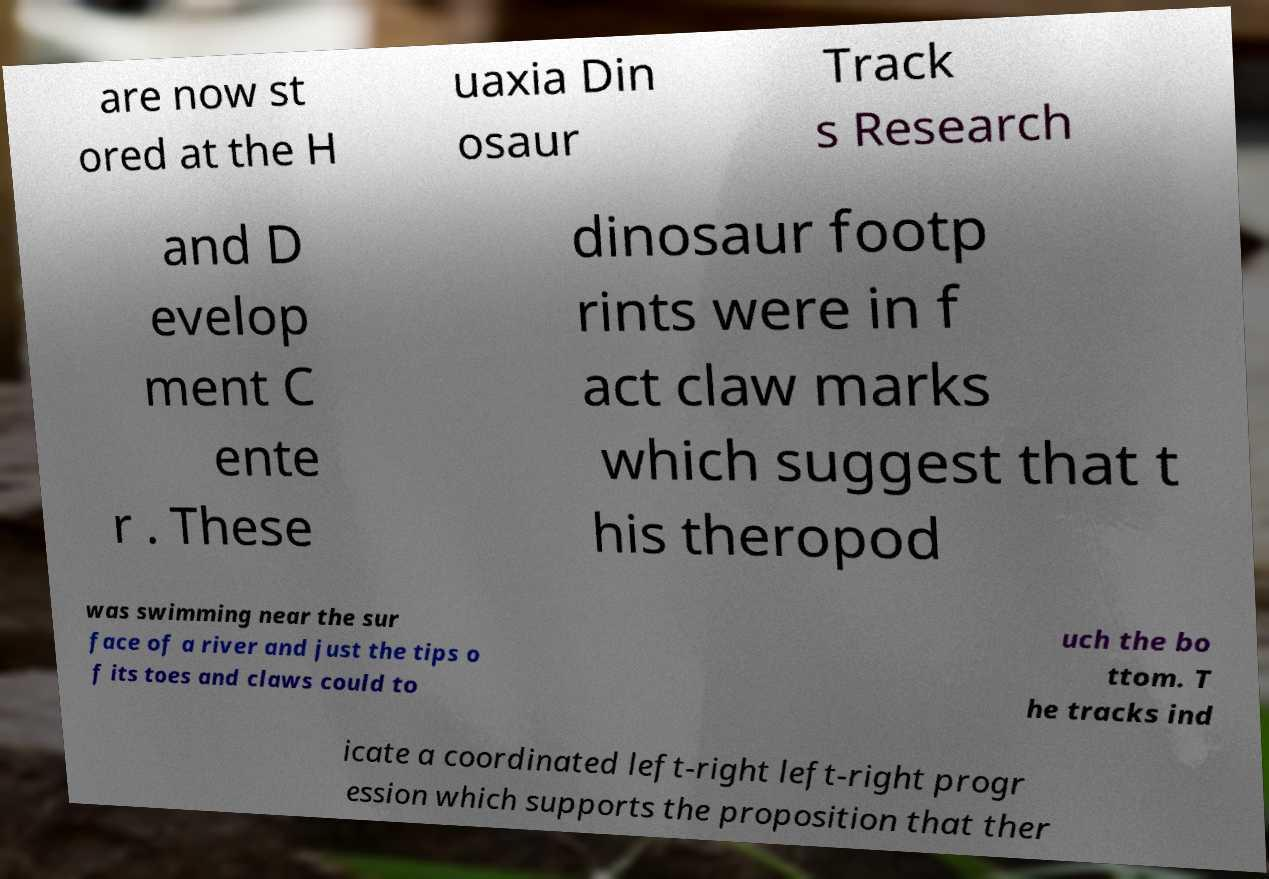Can you read and provide the text displayed in the image?This photo seems to have some interesting text. Can you extract and type it out for me? are now st ored at the H uaxia Din osaur Track s Research and D evelop ment C ente r . These dinosaur footp rints were in f act claw marks which suggest that t his theropod was swimming near the sur face of a river and just the tips o f its toes and claws could to uch the bo ttom. T he tracks ind icate a coordinated left-right left-right progr ession which supports the proposition that ther 